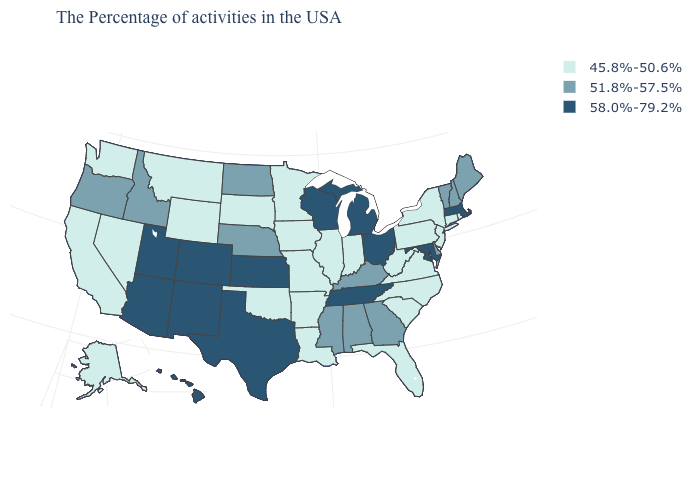Name the states that have a value in the range 58.0%-79.2%?
Be succinct. Massachusetts, Maryland, Ohio, Michigan, Tennessee, Wisconsin, Kansas, Texas, Colorado, New Mexico, Utah, Arizona, Hawaii. What is the value of Arizona?
Keep it brief. 58.0%-79.2%. Name the states that have a value in the range 58.0%-79.2%?
Quick response, please. Massachusetts, Maryland, Ohio, Michigan, Tennessee, Wisconsin, Kansas, Texas, Colorado, New Mexico, Utah, Arizona, Hawaii. How many symbols are there in the legend?
Give a very brief answer. 3. What is the highest value in the USA?
Write a very short answer. 58.0%-79.2%. Which states have the lowest value in the MidWest?
Be succinct. Indiana, Illinois, Missouri, Minnesota, Iowa, South Dakota. Does Missouri have the highest value in the MidWest?
Answer briefly. No. Does Maine have the lowest value in the USA?
Be succinct. No. What is the value of Nebraska?
Answer briefly. 51.8%-57.5%. Among the states that border Kentucky , which have the lowest value?
Concise answer only. Virginia, West Virginia, Indiana, Illinois, Missouri. Among the states that border Vermont , which have the lowest value?
Be succinct. New York. Name the states that have a value in the range 58.0%-79.2%?
Answer briefly. Massachusetts, Maryland, Ohio, Michigan, Tennessee, Wisconsin, Kansas, Texas, Colorado, New Mexico, Utah, Arizona, Hawaii. Does the map have missing data?
Quick response, please. No. Name the states that have a value in the range 51.8%-57.5%?
Give a very brief answer. Maine, New Hampshire, Vermont, Delaware, Georgia, Kentucky, Alabama, Mississippi, Nebraska, North Dakota, Idaho, Oregon. What is the lowest value in the USA?
Answer briefly. 45.8%-50.6%. 